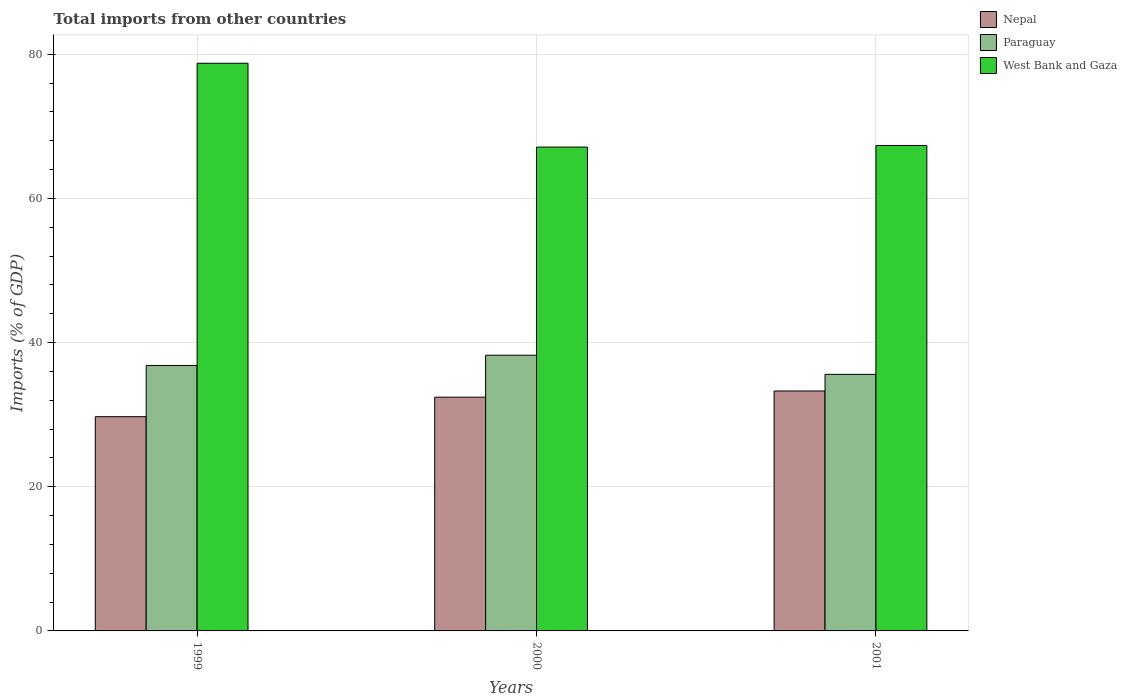How many different coloured bars are there?
Keep it short and to the point. 3. How many groups of bars are there?
Provide a succinct answer. 3. Are the number of bars on each tick of the X-axis equal?
Offer a very short reply. Yes. What is the total imports in Nepal in 2001?
Keep it short and to the point. 33.28. Across all years, what is the maximum total imports in West Bank and Gaza?
Give a very brief answer. 78.75. Across all years, what is the minimum total imports in Nepal?
Offer a very short reply. 29.72. In which year was the total imports in Nepal maximum?
Keep it short and to the point. 2001. In which year was the total imports in West Bank and Gaza minimum?
Your answer should be very brief. 2000. What is the total total imports in Nepal in the graph?
Offer a terse response. 95.43. What is the difference between the total imports in Nepal in 1999 and that in 2000?
Your response must be concise. -2.71. What is the difference between the total imports in West Bank and Gaza in 2001 and the total imports in Nepal in 1999?
Your response must be concise. 37.62. What is the average total imports in Nepal per year?
Give a very brief answer. 31.81. In the year 2001, what is the difference between the total imports in West Bank and Gaza and total imports in Nepal?
Your answer should be compact. 34.06. In how many years, is the total imports in Nepal greater than 60 %?
Your response must be concise. 0. What is the ratio of the total imports in West Bank and Gaza in 1999 to that in 2001?
Your answer should be compact. 1.17. What is the difference between the highest and the second highest total imports in West Bank and Gaza?
Ensure brevity in your answer.  11.41. What is the difference between the highest and the lowest total imports in Paraguay?
Make the answer very short. 2.65. Is the sum of the total imports in West Bank and Gaza in 1999 and 2001 greater than the maximum total imports in Nepal across all years?
Keep it short and to the point. Yes. What does the 3rd bar from the left in 2001 represents?
Give a very brief answer. West Bank and Gaza. What does the 2nd bar from the right in 2000 represents?
Make the answer very short. Paraguay. How many years are there in the graph?
Your answer should be compact. 3. What is the difference between two consecutive major ticks on the Y-axis?
Provide a short and direct response. 20. Are the values on the major ticks of Y-axis written in scientific E-notation?
Your response must be concise. No. Does the graph contain grids?
Provide a succinct answer. Yes. What is the title of the graph?
Your response must be concise. Total imports from other countries. What is the label or title of the X-axis?
Keep it short and to the point. Years. What is the label or title of the Y-axis?
Your answer should be compact. Imports (% of GDP). What is the Imports (% of GDP) of Nepal in 1999?
Ensure brevity in your answer.  29.72. What is the Imports (% of GDP) in Paraguay in 1999?
Offer a terse response. 36.83. What is the Imports (% of GDP) of West Bank and Gaza in 1999?
Provide a succinct answer. 78.75. What is the Imports (% of GDP) of Nepal in 2000?
Provide a succinct answer. 32.43. What is the Imports (% of GDP) of Paraguay in 2000?
Ensure brevity in your answer.  38.25. What is the Imports (% of GDP) in West Bank and Gaza in 2000?
Ensure brevity in your answer.  67.12. What is the Imports (% of GDP) in Nepal in 2001?
Provide a short and direct response. 33.28. What is the Imports (% of GDP) of Paraguay in 2001?
Offer a terse response. 35.59. What is the Imports (% of GDP) of West Bank and Gaza in 2001?
Give a very brief answer. 67.34. Across all years, what is the maximum Imports (% of GDP) of Nepal?
Give a very brief answer. 33.28. Across all years, what is the maximum Imports (% of GDP) in Paraguay?
Offer a terse response. 38.25. Across all years, what is the maximum Imports (% of GDP) in West Bank and Gaza?
Give a very brief answer. 78.75. Across all years, what is the minimum Imports (% of GDP) of Nepal?
Provide a succinct answer. 29.72. Across all years, what is the minimum Imports (% of GDP) of Paraguay?
Ensure brevity in your answer.  35.59. Across all years, what is the minimum Imports (% of GDP) in West Bank and Gaza?
Ensure brevity in your answer.  67.12. What is the total Imports (% of GDP) of Nepal in the graph?
Give a very brief answer. 95.43. What is the total Imports (% of GDP) in Paraguay in the graph?
Offer a very short reply. 110.66. What is the total Imports (% of GDP) in West Bank and Gaza in the graph?
Your answer should be compact. 213.21. What is the difference between the Imports (% of GDP) in Nepal in 1999 and that in 2000?
Provide a succinct answer. -2.71. What is the difference between the Imports (% of GDP) in Paraguay in 1999 and that in 2000?
Provide a succinct answer. -1.42. What is the difference between the Imports (% of GDP) in West Bank and Gaza in 1999 and that in 2000?
Your answer should be very brief. 11.63. What is the difference between the Imports (% of GDP) of Nepal in 1999 and that in 2001?
Your answer should be compact. -3.56. What is the difference between the Imports (% of GDP) of Paraguay in 1999 and that in 2001?
Your response must be concise. 1.23. What is the difference between the Imports (% of GDP) in West Bank and Gaza in 1999 and that in 2001?
Your response must be concise. 11.41. What is the difference between the Imports (% of GDP) in Nepal in 2000 and that in 2001?
Your answer should be compact. -0.86. What is the difference between the Imports (% of GDP) of Paraguay in 2000 and that in 2001?
Give a very brief answer. 2.65. What is the difference between the Imports (% of GDP) in West Bank and Gaza in 2000 and that in 2001?
Make the answer very short. -0.22. What is the difference between the Imports (% of GDP) of Nepal in 1999 and the Imports (% of GDP) of Paraguay in 2000?
Offer a terse response. -8.53. What is the difference between the Imports (% of GDP) in Nepal in 1999 and the Imports (% of GDP) in West Bank and Gaza in 2000?
Ensure brevity in your answer.  -37.4. What is the difference between the Imports (% of GDP) of Paraguay in 1999 and the Imports (% of GDP) of West Bank and Gaza in 2000?
Your answer should be compact. -30.3. What is the difference between the Imports (% of GDP) of Nepal in 1999 and the Imports (% of GDP) of Paraguay in 2001?
Your answer should be compact. -5.87. What is the difference between the Imports (% of GDP) in Nepal in 1999 and the Imports (% of GDP) in West Bank and Gaza in 2001?
Your answer should be very brief. -37.62. What is the difference between the Imports (% of GDP) of Paraguay in 1999 and the Imports (% of GDP) of West Bank and Gaza in 2001?
Make the answer very short. -30.52. What is the difference between the Imports (% of GDP) of Nepal in 2000 and the Imports (% of GDP) of Paraguay in 2001?
Your answer should be compact. -3.17. What is the difference between the Imports (% of GDP) in Nepal in 2000 and the Imports (% of GDP) in West Bank and Gaza in 2001?
Give a very brief answer. -34.92. What is the difference between the Imports (% of GDP) in Paraguay in 2000 and the Imports (% of GDP) in West Bank and Gaza in 2001?
Offer a terse response. -29.1. What is the average Imports (% of GDP) of Nepal per year?
Offer a terse response. 31.81. What is the average Imports (% of GDP) of Paraguay per year?
Your answer should be very brief. 36.89. What is the average Imports (% of GDP) in West Bank and Gaza per year?
Make the answer very short. 71.07. In the year 1999, what is the difference between the Imports (% of GDP) in Nepal and Imports (% of GDP) in Paraguay?
Your answer should be very brief. -7.11. In the year 1999, what is the difference between the Imports (% of GDP) in Nepal and Imports (% of GDP) in West Bank and Gaza?
Your answer should be very brief. -49.03. In the year 1999, what is the difference between the Imports (% of GDP) in Paraguay and Imports (% of GDP) in West Bank and Gaza?
Keep it short and to the point. -41.92. In the year 2000, what is the difference between the Imports (% of GDP) in Nepal and Imports (% of GDP) in Paraguay?
Provide a short and direct response. -5.82. In the year 2000, what is the difference between the Imports (% of GDP) of Nepal and Imports (% of GDP) of West Bank and Gaza?
Your answer should be very brief. -34.7. In the year 2000, what is the difference between the Imports (% of GDP) in Paraguay and Imports (% of GDP) in West Bank and Gaza?
Keep it short and to the point. -28.88. In the year 2001, what is the difference between the Imports (% of GDP) in Nepal and Imports (% of GDP) in Paraguay?
Your response must be concise. -2.31. In the year 2001, what is the difference between the Imports (% of GDP) in Nepal and Imports (% of GDP) in West Bank and Gaza?
Offer a terse response. -34.06. In the year 2001, what is the difference between the Imports (% of GDP) in Paraguay and Imports (% of GDP) in West Bank and Gaza?
Ensure brevity in your answer.  -31.75. What is the ratio of the Imports (% of GDP) of Nepal in 1999 to that in 2000?
Your answer should be very brief. 0.92. What is the ratio of the Imports (% of GDP) in Paraguay in 1999 to that in 2000?
Your answer should be compact. 0.96. What is the ratio of the Imports (% of GDP) in West Bank and Gaza in 1999 to that in 2000?
Your response must be concise. 1.17. What is the ratio of the Imports (% of GDP) in Nepal in 1999 to that in 2001?
Offer a very short reply. 0.89. What is the ratio of the Imports (% of GDP) in Paraguay in 1999 to that in 2001?
Ensure brevity in your answer.  1.03. What is the ratio of the Imports (% of GDP) in West Bank and Gaza in 1999 to that in 2001?
Provide a short and direct response. 1.17. What is the ratio of the Imports (% of GDP) of Nepal in 2000 to that in 2001?
Make the answer very short. 0.97. What is the ratio of the Imports (% of GDP) in Paraguay in 2000 to that in 2001?
Provide a short and direct response. 1.07. What is the difference between the highest and the second highest Imports (% of GDP) of Nepal?
Your answer should be compact. 0.86. What is the difference between the highest and the second highest Imports (% of GDP) in Paraguay?
Keep it short and to the point. 1.42. What is the difference between the highest and the second highest Imports (% of GDP) of West Bank and Gaza?
Your response must be concise. 11.41. What is the difference between the highest and the lowest Imports (% of GDP) of Nepal?
Make the answer very short. 3.56. What is the difference between the highest and the lowest Imports (% of GDP) of Paraguay?
Your answer should be compact. 2.65. What is the difference between the highest and the lowest Imports (% of GDP) in West Bank and Gaza?
Ensure brevity in your answer.  11.63. 